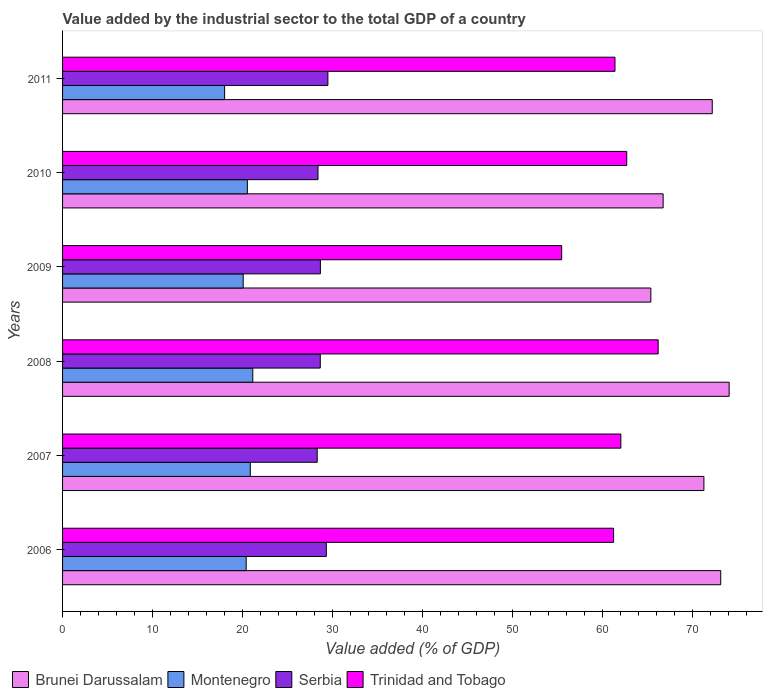How many different coloured bars are there?
Provide a succinct answer. 4. Are the number of bars per tick equal to the number of legend labels?
Your answer should be very brief. Yes. How many bars are there on the 4th tick from the top?
Ensure brevity in your answer.  4. What is the label of the 4th group of bars from the top?
Your answer should be very brief. 2008. In how many cases, is the number of bars for a given year not equal to the number of legend labels?
Offer a very short reply. 0. What is the value added by the industrial sector to the total GDP in Montenegro in 2006?
Make the answer very short. 20.41. Across all years, what is the maximum value added by the industrial sector to the total GDP in Serbia?
Provide a succinct answer. 29.5. Across all years, what is the minimum value added by the industrial sector to the total GDP in Serbia?
Your response must be concise. 28.31. In which year was the value added by the industrial sector to the total GDP in Brunei Darussalam minimum?
Offer a terse response. 2009. What is the total value added by the industrial sector to the total GDP in Brunei Darussalam in the graph?
Your answer should be very brief. 423.01. What is the difference between the value added by the industrial sector to the total GDP in Serbia in 2010 and that in 2011?
Your response must be concise. -1.1. What is the difference between the value added by the industrial sector to the total GDP in Brunei Darussalam in 2006 and the value added by the industrial sector to the total GDP in Montenegro in 2010?
Ensure brevity in your answer.  52.63. What is the average value added by the industrial sector to the total GDP in Brunei Darussalam per year?
Your answer should be compact. 70.5. In the year 2009, what is the difference between the value added by the industrial sector to the total GDP in Trinidad and Tobago and value added by the industrial sector to the total GDP in Brunei Darussalam?
Your answer should be compact. -9.91. What is the ratio of the value added by the industrial sector to the total GDP in Brunei Darussalam in 2006 to that in 2009?
Give a very brief answer. 1.12. Is the value added by the industrial sector to the total GDP in Brunei Darussalam in 2006 less than that in 2008?
Provide a succinct answer. Yes. What is the difference between the highest and the second highest value added by the industrial sector to the total GDP in Montenegro?
Provide a succinct answer. 0.28. What is the difference between the highest and the lowest value added by the industrial sector to the total GDP in Brunei Darussalam?
Offer a terse response. 8.71. What does the 2nd bar from the top in 2007 represents?
Make the answer very short. Serbia. What does the 4th bar from the bottom in 2011 represents?
Your response must be concise. Trinidad and Tobago. Is it the case that in every year, the sum of the value added by the industrial sector to the total GDP in Trinidad and Tobago and value added by the industrial sector to the total GDP in Brunei Darussalam is greater than the value added by the industrial sector to the total GDP in Serbia?
Keep it short and to the point. Yes. How many bars are there?
Give a very brief answer. 24. Are all the bars in the graph horizontal?
Provide a succinct answer. Yes. Does the graph contain any zero values?
Your answer should be very brief. No. How many legend labels are there?
Give a very brief answer. 4. How are the legend labels stacked?
Your response must be concise. Horizontal. What is the title of the graph?
Ensure brevity in your answer.  Value added by the industrial sector to the total GDP of a country. Does "Antigua and Barbuda" appear as one of the legend labels in the graph?
Ensure brevity in your answer.  No. What is the label or title of the X-axis?
Your answer should be very brief. Value added (% of GDP). What is the label or title of the Y-axis?
Offer a very short reply. Years. What is the Value added (% of GDP) of Brunei Darussalam in 2006?
Give a very brief answer. 73.18. What is the Value added (% of GDP) in Montenegro in 2006?
Offer a terse response. 20.41. What is the Value added (% of GDP) of Serbia in 2006?
Offer a very short reply. 29.33. What is the Value added (% of GDP) of Trinidad and Tobago in 2006?
Provide a succinct answer. 61.26. What is the Value added (% of GDP) in Brunei Darussalam in 2007?
Keep it short and to the point. 71.3. What is the Value added (% of GDP) of Montenegro in 2007?
Offer a very short reply. 20.87. What is the Value added (% of GDP) of Serbia in 2007?
Give a very brief answer. 28.31. What is the Value added (% of GDP) of Trinidad and Tobago in 2007?
Your answer should be very brief. 62.07. What is the Value added (% of GDP) in Brunei Darussalam in 2008?
Your response must be concise. 74.11. What is the Value added (% of GDP) in Montenegro in 2008?
Offer a terse response. 21.15. What is the Value added (% of GDP) of Serbia in 2008?
Make the answer very short. 28.65. What is the Value added (% of GDP) of Trinidad and Tobago in 2008?
Offer a very short reply. 66.22. What is the Value added (% of GDP) of Brunei Darussalam in 2009?
Ensure brevity in your answer.  65.41. What is the Value added (% of GDP) in Montenegro in 2009?
Provide a succinct answer. 20.08. What is the Value added (% of GDP) in Serbia in 2009?
Your response must be concise. 28.67. What is the Value added (% of GDP) of Trinidad and Tobago in 2009?
Your answer should be very brief. 55.49. What is the Value added (% of GDP) in Brunei Darussalam in 2010?
Provide a succinct answer. 66.77. What is the Value added (% of GDP) in Montenegro in 2010?
Provide a succinct answer. 20.54. What is the Value added (% of GDP) of Serbia in 2010?
Make the answer very short. 28.4. What is the Value added (% of GDP) in Trinidad and Tobago in 2010?
Provide a short and direct response. 62.72. What is the Value added (% of GDP) in Brunei Darussalam in 2011?
Give a very brief answer. 72.23. What is the Value added (% of GDP) in Montenegro in 2011?
Ensure brevity in your answer.  18.02. What is the Value added (% of GDP) in Serbia in 2011?
Offer a terse response. 29.5. What is the Value added (% of GDP) in Trinidad and Tobago in 2011?
Provide a succinct answer. 61.42. Across all years, what is the maximum Value added (% of GDP) in Brunei Darussalam?
Provide a succinct answer. 74.11. Across all years, what is the maximum Value added (% of GDP) in Montenegro?
Give a very brief answer. 21.15. Across all years, what is the maximum Value added (% of GDP) of Serbia?
Ensure brevity in your answer.  29.5. Across all years, what is the maximum Value added (% of GDP) of Trinidad and Tobago?
Your answer should be very brief. 66.22. Across all years, what is the minimum Value added (% of GDP) of Brunei Darussalam?
Your answer should be very brief. 65.41. Across all years, what is the minimum Value added (% of GDP) of Montenegro?
Ensure brevity in your answer.  18.02. Across all years, what is the minimum Value added (% of GDP) in Serbia?
Offer a very short reply. 28.31. Across all years, what is the minimum Value added (% of GDP) of Trinidad and Tobago?
Make the answer very short. 55.49. What is the total Value added (% of GDP) in Brunei Darussalam in the graph?
Keep it short and to the point. 423.01. What is the total Value added (% of GDP) of Montenegro in the graph?
Provide a short and direct response. 121.08. What is the total Value added (% of GDP) of Serbia in the graph?
Ensure brevity in your answer.  172.85. What is the total Value added (% of GDP) of Trinidad and Tobago in the graph?
Your response must be concise. 369.19. What is the difference between the Value added (% of GDP) in Brunei Darussalam in 2006 and that in 2007?
Make the answer very short. 1.87. What is the difference between the Value added (% of GDP) in Montenegro in 2006 and that in 2007?
Your answer should be very brief. -0.46. What is the difference between the Value added (% of GDP) in Serbia in 2006 and that in 2007?
Your answer should be very brief. 1.02. What is the difference between the Value added (% of GDP) in Trinidad and Tobago in 2006 and that in 2007?
Keep it short and to the point. -0.81. What is the difference between the Value added (% of GDP) of Brunei Darussalam in 2006 and that in 2008?
Offer a very short reply. -0.94. What is the difference between the Value added (% of GDP) in Montenegro in 2006 and that in 2008?
Provide a short and direct response. -0.73. What is the difference between the Value added (% of GDP) in Serbia in 2006 and that in 2008?
Give a very brief answer. 0.67. What is the difference between the Value added (% of GDP) in Trinidad and Tobago in 2006 and that in 2008?
Provide a succinct answer. -4.96. What is the difference between the Value added (% of GDP) in Brunei Darussalam in 2006 and that in 2009?
Your answer should be very brief. 7.77. What is the difference between the Value added (% of GDP) in Montenegro in 2006 and that in 2009?
Offer a terse response. 0.33. What is the difference between the Value added (% of GDP) in Serbia in 2006 and that in 2009?
Make the answer very short. 0.66. What is the difference between the Value added (% of GDP) of Trinidad and Tobago in 2006 and that in 2009?
Provide a short and direct response. 5.77. What is the difference between the Value added (% of GDP) in Brunei Darussalam in 2006 and that in 2010?
Make the answer very short. 6.4. What is the difference between the Value added (% of GDP) of Montenegro in 2006 and that in 2010?
Offer a terse response. -0.13. What is the difference between the Value added (% of GDP) in Serbia in 2006 and that in 2010?
Provide a short and direct response. 0.93. What is the difference between the Value added (% of GDP) of Trinidad and Tobago in 2006 and that in 2010?
Ensure brevity in your answer.  -1.46. What is the difference between the Value added (% of GDP) of Brunei Darussalam in 2006 and that in 2011?
Provide a succinct answer. 0.94. What is the difference between the Value added (% of GDP) of Montenegro in 2006 and that in 2011?
Your answer should be very brief. 2.4. What is the difference between the Value added (% of GDP) in Serbia in 2006 and that in 2011?
Your answer should be compact. -0.17. What is the difference between the Value added (% of GDP) of Trinidad and Tobago in 2006 and that in 2011?
Provide a succinct answer. -0.15. What is the difference between the Value added (% of GDP) in Brunei Darussalam in 2007 and that in 2008?
Keep it short and to the point. -2.81. What is the difference between the Value added (% of GDP) in Montenegro in 2007 and that in 2008?
Give a very brief answer. -0.28. What is the difference between the Value added (% of GDP) in Serbia in 2007 and that in 2008?
Make the answer very short. -0.34. What is the difference between the Value added (% of GDP) of Trinidad and Tobago in 2007 and that in 2008?
Your response must be concise. -4.15. What is the difference between the Value added (% of GDP) in Brunei Darussalam in 2007 and that in 2009?
Offer a very short reply. 5.9. What is the difference between the Value added (% of GDP) of Montenegro in 2007 and that in 2009?
Your answer should be very brief. 0.79. What is the difference between the Value added (% of GDP) in Serbia in 2007 and that in 2009?
Keep it short and to the point. -0.36. What is the difference between the Value added (% of GDP) of Trinidad and Tobago in 2007 and that in 2009?
Ensure brevity in your answer.  6.58. What is the difference between the Value added (% of GDP) in Brunei Darussalam in 2007 and that in 2010?
Offer a very short reply. 4.53. What is the difference between the Value added (% of GDP) in Montenegro in 2007 and that in 2010?
Make the answer very short. 0.33. What is the difference between the Value added (% of GDP) of Serbia in 2007 and that in 2010?
Offer a very short reply. -0.09. What is the difference between the Value added (% of GDP) of Trinidad and Tobago in 2007 and that in 2010?
Your response must be concise. -0.65. What is the difference between the Value added (% of GDP) of Brunei Darussalam in 2007 and that in 2011?
Give a very brief answer. -0.93. What is the difference between the Value added (% of GDP) in Montenegro in 2007 and that in 2011?
Offer a terse response. 2.86. What is the difference between the Value added (% of GDP) in Serbia in 2007 and that in 2011?
Make the answer very short. -1.19. What is the difference between the Value added (% of GDP) in Trinidad and Tobago in 2007 and that in 2011?
Provide a succinct answer. 0.65. What is the difference between the Value added (% of GDP) in Brunei Darussalam in 2008 and that in 2009?
Provide a short and direct response. 8.71. What is the difference between the Value added (% of GDP) in Montenegro in 2008 and that in 2009?
Offer a very short reply. 1.07. What is the difference between the Value added (% of GDP) of Serbia in 2008 and that in 2009?
Offer a terse response. -0.01. What is the difference between the Value added (% of GDP) in Trinidad and Tobago in 2008 and that in 2009?
Provide a short and direct response. 10.73. What is the difference between the Value added (% of GDP) of Brunei Darussalam in 2008 and that in 2010?
Your response must be concise. 7.34. What is the difference between the Value added (% of GDP) in Montenegro in 2008 and that in 2010?
Ensure brevity in your answer.  0.6. What is the difference between the Value added (% of GDP) in Serbia in 2008 and that in 2010?
Provide a succinct answer. 0.25. What is the difference between the Value added (% of GDP) in Trinidad and Tobago in 2008 and that in 2010?
Your answer should be compact. 3.5. What is the difference between the Value added (% of GDP) in Brunei Darussalam in 2008 and that in 2011?
Your response must be concise. 1.88. What is the difference between the Value added (% of GDP) of Montenegro in 2008 and that in 2011?
Keep it short and to the point. 3.13. What is the difference between the Value added (% of GDP) of Serbia in 2008 and that in 2011?
Offer a terse response. -0.85. What is the difference between the Value added (% of GDP) of Trinidad and Tobago in 2008 and that in 2011?
Your response must be concise. 4.8. What is the difference between the Value added (% of GDP) in Brunei Darussalam in 2009 and that in 2010?
Give a very brief answer. -1.37. What is the difference between the Value added (% of GDP) of Montenegro in 2009 and that in 2010?
Offer a very short reply. -0.46. What is the difference between the Value added (% of GDP) in Serbia in 2009 and that in 2010?
Keep it short and to the point. 0.27. What is the difference between the Value added (% of GDP) of Trinidad and Tobago in 2009 and that in 2010?
Keep it short and to the point. -7.23. What is the difference between the Value added (% of GDP) in Brunei Darussalam in 2009 and that in 2011?
Your answer should be compact. -6.83. What is the difference between the Value added (% of GDP) of Montenegro in 2009 and that in 2011?
Give a very brief answer. 2.07. What is the difference between the Value added (% of GDP) of Serbia in 2009 and that in 2011?
Offer a terse response. -0.83. What is the difference between the Value added (% of GDP) in Trinidad and Tobago in 2009 and that in 2011?
Provide a succinct answer. -5.93. What is the difference between the Value added (% of GDP) in Brunei Darussalam in 2010 and that in 2011?
Your response must be concise. -5.46. What is the difference between the Value added (% of GDP) in Montenegro in 2010 and that in 2011?
Offer a very short reply. 2.53. What is the difference between the Value added (% of GDP) in Serbia in 2010 and that in 2011?
Make the answer very short. -1.1. What is the difference between the Value added (% of GDP) in Trinidad and Tobago in 2010 and that in 2011?
Provide a short and direct response. 1.31. What is the difference between the Value added (% of GDP) in Brunei Darussalam in 2006 and the Value added (% of GDP) in Montenegro in 2007?
Provide a short and direct response. 52.3. What is the difference between the Value added (% of GDP) in Brunei Darussalam in 2006 and the Value added (% of GDP) in Serbia in 2007?
Provide a succinct answer. 44.87. What is the difference between the Value added (% of GDP) of Brunei Darussalam in 2006 and the Value added (% of GDP) of Trinidad and Tobago in 2007?
Offer a very short reply. 11.11. What is the difference between the Value added (% of GDP) in Montenegro in 2006 and the Value added (% of GDP) in Serbia in 2007?
Your answer should be compact. -7.9. What is the difference between the Value added (% of GDP) of Montenegro in 2006 and the Value added (% of GDP) of Trinidad and Tobago in 2007?
Offer a terse response. -41.66. What is the difference between the Value added (% of GDP) of Serbia in 2006 and the Value added (% of GDP) of Trinidad and Tobago in 2007?
Provide a short and direct response. -32.74. What is the difference between the Value added (% of GDP) in Brunei Darussalam in 2006 and the Value added (% of GDP) in Montenegro in 2008?
Give a very brief answer. 52.03. What is the difference between the Value added (% of GDP) in Brunei Darussalam in 2006 and the Value added (% of GDP) in Serbia in 2008?
Your answer should be compact. 44.52. What is the difference between the Value added (% of GDP) in Brunei Darussalam in 2006 and the Value added (% of GDP) in Trinidad and Tobago in 2008?
Give a very brief answer. 6.96. What is the difference between the Value added (% of GDP) of Montenegro in 2006 and the Value added (% of GDP) of Serbia in 2008?
Provide a succinct answer. -8.24. What is the difference between the Value added (% of GDP) in Montenegro in 2006 and the Value added (% of GDP) in Trinidad and Tobago in 2008?
Your answer should be very brief. -45.81. What is the difference between the Value added (% of GDP) in Serbia in 2006 and the Value added (% of GDP) in Trinidad and Tobago in 2008?
Make the answer very short. -36.89. What is the difference between the Value added (% of GDP) in Brunei Darussalam in 2006 and the Value added (% of GDP) in Montenegro in 2009?
Provide a short and direct response. 53.1. What is the difference between the Value added (% of GDP) in Brunei Darussalam in 2006 and the Value added (% of GDP) in Serbia in 2009?
Your answer should be compact. 44.51. What is the difference between the Value added (% of GDP) of Brunei Darussalam in 2006 and the Value added (% of GDP) of Trinidad and Tobago in 2009?
Offer a very short reply. 17.69. What is the difference between the Value added (% of GDP) of Montenegro in 2006 and the Value added (% of GDP) of Serbia in 2009?
Your answer should be very brief. -8.25. What is the difference between the Value added (% of GDP) in Montenegro in 2006 and the Value added (% of GDP) in Trinidad and Tobago in 2009?
Provide a short and direct response. -35.08. What is the difference between the Value added (% of GDP) of Serbia in 2006 and the Value added (% of GDP) of Trinidad and Tobago in 2009?
Your answer should be very brief. -26.17. What is the difference between the Value added (% of GDP) of Brunei Darussalam in 2006 and the Value added (% of GDP) of Montenegro in 2010?
Your answer should be compact. 52.63. What is the difference between the Value added (% of GDP) in Brunei Darussalam in 2006 and the Value added (% of GDP) in Serbia in 2010?
Keep it short and to the point. 44.78. What is the difference between the Value added (% of GDP) of Brunei Darussalam in 2006 and the Value added (% of GDP) of Trinidad and Tobago in 2010?
Ensure brevity in your answer.  10.45. What is the difference between the Value added (% of GDP) of Montenegro in 2006 and the Value added (% of GDP) of Serbia in 2010?
Give a very brief answer. -7.99. What is the difference between the Value added (% of GDP) in Montenegro in 2006 and the Value added (% of GDP) in Trinidad and Tobago in 2010?
Provide a short and direct response. -42.31. What is the difference between the Value added (% of GDP) in Serbia in 2006 and the Value added (% of GDP) in Trinidad and Tobago in 2010?
Offer a terse response. -33.4. What is the difference between the Value added (% of GDP) of Brunei Darussalam in 2006 and the Value added (% of GDP) of Montenegro in 2011?
Your answer should be compact. 55.16. What is the difference between the Value added (% of GDP) in Brunei Darussalam in 2006 and the Value added (% of GDP) in Serbia in 2011?
Your answer should be very brief. 43.68. What is the difference between the Value added (% of GDP) of Brunei Darussalam in 2006 and the Value added (% of GDP) of Trinidad and Tobago in 2011?
Your response must be concise. 11.76. What is the difference between the Value added (% of GDP) in Montenegro in 2006 and the Value added (% of GDP) in Serbia in 2011?
Offer a very short reply. -9.08. What is the difference between the Value added (% of GDP) in Montenegro in 2006 and the Value added (% of GDP) in Trinidad and Tobago in 2011?
Your answer should be compact. -41. What is the difference between the Value added (% of GDP) in Serbia in 2006 and the Value added (% of GDP) in Trinidad and Tobago in 2011?
Provide a succinct answer. -32.09. What is the difference between the Value added (% of GDP) of Brunei Darussalam in 2007 and the Value added (% of GDP) of Montenegro in 2008?
Provide a short and direct response. 50.16. What is the difference between the Value added (% of GDP) of Brunei Darussalam in 2007 and the Value added (% of GDP) of Serbia in 2008?
Give a very brief answer. 42.65. What is the difference between the Value added (% of GDP) in Brunei Darussalam in 2007 and the Value added (% of GDP) in Trinidad and Tobago in 2008?
Keep it short and to the point. 5.08. What is the difference between the Value added (% of GDP) of Montenegro in 2007 and the Value added (% of GDP) of Serbia in 2008?
Your answer should be compact. -7.78. What is the difference between the Value added (% of GDP) in Montenegro in 2007 and the Value added (% of GDP) in Trinidad and Tobago in 2008?
Offer a terse response. -45.35. What is the difference between the Value added (% of GDP) of Serbia in 2007 and the Value added (% of GDP) of Trinidad and Tobago in 2008?
Offer a very short reply. -37.91. What is the difference between the Value added (% of GDP) in Brunei Darussalam in 2007 and the Value added (% of GDP) in Montenegro in 2009?
Give a very brief answer. 51.22. What is the difference between the Value added (% of GDP) in Brunei Darussalam in 2007 and the Value added (% of GDP) in Serbia in 2009?
Your answer should be very brief. 42.64. What is the difference between the Value added (% of GDP) in Brunei Darussalam in 2007 and the Value added (% of GDP) in Trinidad and Tobago in 2009?
Your answer should be very brief. 15.81. What is the difference between the Value added (% of GDP) in Montenegro in 2007 and the Value added (% of GDP) in Serbia in 2009?
Make the answer very short. -7.79. What is the difference between the Value added (% of GDP) in Montenegro in 2007 and the Value added (% of GDP) in Trinidad and Tobago in 2009?
Make the answer very short. -34.62. What is the difference between the Value added (% of GDP) of Serbia in 2007 and the Value added (% of GDP) of Trinidad and Tobago in 2009?
Provide a succinct answer. -27.18. What is the difference between the Value added (% of GDP) in Brunei Darussalam in 2007 and the Value added (% of GDP) in Montenegro in 2010?
Provide a short and direct response. 50.76. What is the difference between the Value added (% of GDP) of Brunei Darussalam in 2007 and the Value added (% of GDP) of Serbia in 2010?
Keep it short and to the point. 42.9. What is the difference between the Value added (% of GDP) of Brunei Darussalam in 2007 and the Value added (% of GDP) of Trinidad and Tobago in 2010?
Ensure brevity in your answer.  8.58. What is the difference between the Value added (% of GDP) of Montenegro in 2007 and the Value added (% of GDP) of Serbia in 2010?
Offer a terse response. -7.53. What is the difference between the Value added (% of GDP) in Montenegro in 2007 and the Value added (% of GDP) in Trinidad and Tobago in 2010?
Give a very brief answer. -41.85. What is the difference between the Value added (% of GDP) in Serbia in 2007 and the Value added (% of GDP) in Trinidad and Tobago in 2010?
Provide a succinct answer. -34.41. What is the difference between the Value added (% of GDP) in Brunei Darussalam in 2007 and the Value added (% of GDP) in Montenegro in 2011?
Your answer should be very brief. 53.29. What is the difference between the Value added (% of GDP) of Brunei Darussalam in 2007 and the Value added (% of GDP) of Serbia in 2011?
Make the answer very short. 41.81. What is the difference between the Value added (% of GDP) of Brunei Darussalam in 2007 and the Value added (% of GDP) of Trinidad and Tobago in 2011?
Offer a very short reply. 9.89. What is the difference between the Value added (% of GDP) in Montenegro in 2007 and the Value added (% of GDP) in Serbia in 2011?
Give a very brief answer. -8.63. What is the difference between the Value added (% of GDP) of Montenegro in 2007 and the Value added (% of GDP) of Trinidad and Tobago in 2011?
Give a very brief answer. -40.55. What is the difference between the Value added (% of GDP) of Serbia in 2007 and the Value added (% of GDP) of Trinidad and Tobago in 2011?
Keep it short and to the point. -33.11. What is the difference between the Value added (% of GDP) of Brunei Darussalam in 2008 and the Value added (% of GDP) of Montenegro in 2009?
Your answer should be very brief. 54.03. What is the difference between the Value added (% of GDP) in Brunei Darussalam in 2008 and the Value added (% of GDP) in Serbia in 2009?
Offer a terse response. 45.45. What is the difference between the Value added (% of GDP) of Brunei Darussalam in 2008 and the Value added (% of GDP) of Trinidad and Tobago in 2009?
Provide a succinct answer. 18.62. What is the difference between the Value added (% of GDP) of Montenegro in 2008 and the Value added (% of GDP) of Serbia in 2009?
Make the answer very short. -7.52. What is the difference between the Value added (% of GDP) of Montenegro in 2008 and the Value added (% of GDP) of Trinidad and Tobago in 2009?
Make the answer very short. -34.34. What is the difference between the Value added (% of GDP) of Serbia in 2008 and the Value added (% of GDP) of Trinidad and Tobago in 2009?
Give a very brief answer. -26.84. What is the difference between the Value added (% of GDP) of Brunei Darussalam in 2008 and the Value added (% of GDP) of Montenegro in 2010?
Make the answer very short. 53.57. What is the difference between the Value added (% of GDP) in Brunei Darussalam in 2008 and the Value added (% of GDP) in Serbia in 2010?
Ensure brevity in your answer.  45.71. What is the difference between the Value added (% of GDP) in Brunei Darussalam in 2008 and the Value added (% of GDP) in Trinidad and Tobago in 2010?
Make the answer very short. 11.39. What is the difference between the Value added (% of GDP) of Montenegro in 2008 and the Value added (% of GDP) of Serbia in 2010?
Your answer should be very brief. -7.25. What is the difference between the Value added (% of GDP) in Montenegro in 2008 and the Value added (% of GDP) in Trinidad and Tobago in 2010?
Your answer should be very brief. -41.58. What is the difference between the Value added (% of GDP) of Serbia in 2008 and the Value added (% of GDP) of Trinidad and Tobago in 2010?
Offer a terse response. -34.07. What is the difference between the Value added (% of GDP) in Brunei Darussalam in 2008 and the Value added (% of GDP) in Montenegro in 2011?
Your response must be concise. 56.1. What is the difference between the Value added (% of GDP) of Brunei Darussalam in 2008 and the Value added (% of GDP) of Serbia in 2011?
Provide a succinct answer. 44.61. What is the difference between the Value added (% of GDP) of Brunei Darussalam in 2008 and the Value added (% of GDP) of Trinidad and Tobago in 2011?
Ensure brevity in your answer.  12.69. What is the difference between the Value added (% of GDP) in Montenegro in 2008 and the Value added (% of GDP) in Serbia in 2011?
Give a very brief answer. -8.35. What is the difference between the Value added (% of GDP) in Montenegro in 2008 and the Value added (% of GDP) in Trinidad and Tobago in 2011?
Provide a succinct answer. -40.27. What is the difference between the Value added (% of GDP) of Serbia in 2008 and the Value added (% of GDP) of Trinidad and Tobago in 2011?
Offer a terse response. -32.77. What is the difference between the Value added (% of GDP) of Brunei Darussalam in 2009 and the Value added (% of GDP) of Montenegro in 2010?
Your answer should be very brief. 44.86. What is the difference between the Value added (% of GDP) in Brunei Darussalam in 2009 and the Value added (% of GDP) in Serbia in 2010?
Ensure brevity in your answer.  37.01. What is the difference between the Value added (% of GDP) in Brunei Darussalam in 2009 and the Value added (% of GDP) in Trinidad and Tobago in 2010?
Your answer should be compact. 2.68. What is the difference between the Value added (% of GDP) of Montenegro in 2009 and the Value added (% of GDP) of Serbia in 2010?
Provide a short and direct response. -8.32. What is the difference between the Value added (% of GDP) of Montenegro in 2009 and the Value added (% of GDP) of Trinidad and Tobago in 2010?
Your response must be concise. -42.64. What is the difference between the Value added (% of GDP) in Serbia in 2009 and the Value added (% of GDP) in Trinidad and Tobago in 2010?
Offer a terse response. -34.06. What is the difference between the Value added (% of GDP) in Brunei Darussalam in 2009 and the Value added (% of GDP) in Montenegro in 2011?
Your response must be concise. 47.39. What is the difference between the Value added (% of GDP) of Brunei Darussalam in 2009 and the Value added (% of GDP) of Serbia in 2011?
Provide a short and direct response. 35.91. What is the difference between the Value added (% of GDP) of Brunei Darussalam in 2009 and the Value added (% of GDP) of Trinidad and Tobago in 2011?
Your answer should be very brief. 3.99. What is the difference between the Value added (% of GDP) of Montenegro in 2009 and the Value added (% of GDP) of Serbia in 2011?
Your answer should be very brief. -9.42. What is the difference between the Value added (% of GDP) in Montenegro in 2009 and the Value added (% of GDP) in Trinidad and Tobago in 2011?
Offer a terse response. -41.34. What is the difference between the Value added (% of GDP) of Serbia in 2009 and the Value added (% of GDP) of Trinidad and Tobago in 2011?
Make the answer very short. -32.75. What is the difference between the Value added (% of GDP) in Brunei Darussalam in 2010 and the Value added (% of GDP) in Montenegro in 2011?
Make the answer very short. 48.76. What is the difference between the Value added (% of GDP) in Brunei Darussalam in 2010 and the Value added (% of GDP) in Serbia in 2011?
Ensure brevity in your answer.  37.27. What is the difference between the Value added (% of GDP) in Brunei Darussalam in 2010 and the Value added (% of GDP) in Trinidad and Tobago in 2011?
Offer a very short reply. 5.36. What is the difference between the Value added (% of GDP) of Montenegro in 2010 and the Value added (% of GDP) of Serbia in 2011?
Offer a very short reply. -8.95. What is the difference between the Value added (% of GDP) in Montenegro in 2010 and the Value added (% of GDP) in Trinidad and Tobago in 2011?
Make the answer very short. -40.87. What is the difference between the Value added (% of GDP) of Serbia in 2010 and the Value added (% of GDP) of Trinidad and Tobago in 2011?
Provide a succinct answer. -33.02. What is the average Value added (% of GDP) of Brunei Darussalam per year?
Your answer should be very brief. 70.5. What is the average Value added (% of GDP) of Montenegro per year?
Give a very brief answer. 20.18. What is the average Value added (% of GDP) of Serbia per year?
Offer a terse response. 28.81. What is the average Value added (% of GDP) of Trinidad and Tobago per year?
Offer a terse response. 61.53. In the year 2006, what is the difference between the Value added (% of GDP) in Brunei Darussalam and Value added (% of GDP) in Montenegro?
Give a very brief answer. 52.76. In the year 2006, what is the difference between the Value added (% of GDP) of Brunei Darussalam and Value added (% of GDP) of Serbia?
Your response must be concise. 43.85. In the year 2006, what is the difference between the Value added (% of GDP) of Brunei Darussalam and Value added (% of GDP) of Trinidad and Tobago?
Your response must be concise. 11.91. In the year 2006, what is the difference between the Value added (% of GDP) in Montenegro and Value added (% of GDP) in Serbia?
Keep it short and to the point. -8.91. In the year 2006, what is the difference between the Value added (% of GDP) in Montenegro and Value added (% of GDP) in Trinidad and Tobago?
Your answer should be compact. -40.85. In the year 2006, what is the difference between the Value added (% of GDP) of Serbia and Value added (% of GDP) of Trinidad and Tobago?
Provide a short and direct response. -31.94. In the year 2007, what is the difference between the Value added (% of GDP) of Brunei Darussalam and Value added (% of GDP) of Montenegro?
Give a very brief answer. 50.43. In the year 2007, what is the difference between the Value added (% of GDP) of Brunei Darussalam and Value added (% of GDP) of Serbia?
Your response must be concise. 42.99. In the year 2007, what is the difference between the Value added (% of GDP) in Brunei Darussalam and Value added (% of GDP) in Trinidad and Tobago?
Your answer should be very brief. 9.23. In the year 2007, what is the difference between the Value added (% of GDP) of Montenegro and Value added (% of GDP) of Serbia?
Offer a very short reply. -7.44. In the year 2007, what is the difference between the Value added (% of GDP) in Montenegro and Value added (% of GDP) in Trinidad and Tobago?
Provide a short and direct response. -41.2. In the year 2007, what is the difference between the Value added (% of GDP) in Serbia and Value added (% of GDP) in Trinidad and Tobago?
Offer a terse response. -33.76. In the year 2008, what is the difference between the Value added (% of GDP) in Brunei Darussalam and Value added (% of GDP) in Montenegro?
Provide a short and direct response. 52.96. In the year 2008, what is the difference between the Value added (% of GDP) of Brunei Darussalam and Value added (% of GDP) of Serbia?
Ensure brevity in your answer.  45.46. In the year 2008, what is the difference between the Value added (% of GDP) of Brunei Darussalam and Value added (% of GDP) of Trinidad and Tobago?
Offer a very short reply. 7.89. In the year 2008, what is the difference between the Value added (% of GDP) in Montenegro and Value added (% of GDP) in Serbia?
Provide a succinct answer. -7.5. In the year 2008, what is the difference between the Value added (% of GDP) in Montenegro and Value added (% of GDP) in Trinidad and Tobago?
Make the answer very short. -45.07. In the year 2008, what is the difference between the Value added (% of GDP) in Serbia and Value added (% of GDP) in Trinidad and Tobago?
Give a very brief answer. -37.57. In the year 2009, what is the difference between the Value added (% of GDP) in Brunei Darussalam and Value added (% of GDP) in Montenegro?
Ensure brevity in your answer.  45.32. In the year 2009, what is the difference between the Value added (% of GDP) in Brunei Darussalam and Value added (% of GDP) in Serbia?
Keep it short and to the point. 36.74. In the year 2009, what is the difference between the Value added (% of GDP) of Brunei Darussalam and Value added (% of GDP) of Trinidad and Tobago?
Offer a terse response. 9.91. In the year 2009, what is the difference between the Value added (% of GDP) in Montenegro and Value added (% of GDP) in Serbia?
Offer a very short reply. -8.58. In the year 2009, what is the difference between the Value added (% of GDP) of Montenegro and Value added (% of GDP) of Trinidad and Tobago?
Provide a short and direct response. -35.41. In the year 2009, what is the difference between the Value added (% of GDP) of Serbia and Value added (% of GDP) of Trinidad and Tobago?
Offer a terse response. -26.83. In the year 2010, what is the difference between the Value added (% of GDP) in Brunei Darussalam and Value added (% of GDP) in Montenegro?
Your answer should be compact. 46.23. In the year 2010, what is the difference between the Value added (% of GDP) of Brunei Darussalam and Value added (% of GDP) of Serbia?
Keep it short and to the point. 38.37. In the year 2010, what is the difference between the Value added (% of GDP) of Brunei Darussalam and Value added (% of GDP) of Trinidad and Tobago?
Make the answer very short. 4.05. In the year 2010, what is the difference between the Value added (% of GDP) of Montenegro and Value added (% of GDP) of Serbia?
Keep it short and to the point. -7.86. In the year 2010, what is the difference between the Value added (% of GDP) of Montenegro and Value added (% of GDP) of Trinidad and Tobago?
Your response must be concise. -42.18. In the year 2010, what is the difference between the Value added (% of GDP) in Serbia and Value added (% of GDP) in Trinidad and Tobago?
Keep it short and to the point. -34.32. In the year 2011, what is the difference between the Value added (% of GDP) of Brunei Darussalam and Value added (% of GDP) of Montenegro?
Provide a succinct answer. 54.22. In the year 2011, what is the difference between the Value added (% of GDP) of Brunei Darussalam and Value added (% of GDP) of Serbia?
Keep it short and to the point. 42.73. In the year 2011, what is the difference between the Value added (% of GDP) of Brunei Darussalam and Value added (% of GDP) of Trinidad and Tobago?
Ensure brevity in your answer.  10.82. In the year 2011, what is the difference between the Value added (% of GDP) of Montenegro and Value added (% of GDP) of Serbia?
Offer a very short reply. -11.48. In the year 2011, what is the difference between the Value added (% of GDP) of Montenegro and Value added (% of GDP) of Trinidad and Tobago?
Your answer should be compact. -43.4. In the year 2011, what is the difference between the Value added (% of GDP) of Serbia and Value added (% of GDP) of Trinidad and Tobago?
Your answer should be compact. -31.92. What is the ratio of the Value added (% of GDP) in Brunei Darussalam in 2006 to that in 2007?
Offer a very short reply. 1.03. What is the ratio of the Value added (% of GDP) in Montenegro in 2006 to that in 2007?
Your response must be concise. 0.98. What is the ratio of the Value added (% of GDP) in Serbia in 2006 to that in 2007?
Your answer should be compact. 1.04. What is the ratio of the Value added (% of GDP) of Trinidad and Tobago in 2006 to that in 2007?
Your response must be concise. 0.99. What is the ratio of the Value added (% of GDP) in Brunei Darussalam in 2006 to that in 2008?
Provide a succinct answer. 0.99. What is the ratio of the Value added (% of GDP) of Montenegro in 2006 to that in 2008?
Provide a succinct answer. 0.97. What is the ratio of the Value added (% of GDP) of Serbia in 2006 to that in 2008?
Give a very brief answer. 1.02. What is the ratio of the Value added (% of GDP) of Trinidad and Tobago in 2006 to that in 2008?
Make the answer very short. 0.93. What is the ratio of the Value added (% of GDP) of Brunei Darussalam in 2006 to that in 2009?
Provide a succinct answer. 1.12. What is the ratio of the Value added (% of GDP) of Montenegro in 2006 to that in 2009?
Your answer should be very brief. 1.02. What is the ratio of the Value added (% of GDP) of Trinidad and Tobago in 2006 to that in 2009?
Give a very brief answer. 1.1. What is the ratio of the Value added (% of GDP) in Brunei Darussalam in 2006 to that in 2010?
Offer a terse response. 1.1. What is the ratio of the Value added (% of GDP) in Montenegro in 2006 to that in 2010?
Keep it short and to the point. 0.99. What is the ratio of the Value added (% of GDP) of Serbia in 2006 to that in 2010?
Provide a succinct answer. 1.03. What is the ratio of the Value added (% of GDP) in Trinidad and Tobago in 2006 to that in 2010?
Keep it short and to the point. 0.98. What is the ratio of the Value added (% of GDP) of Brunei Darussalam in 2006 to that in 2011?
Your answer should be compact. 1.01. What is the ratio of the Value added (% of GDP) of Montenegro in 2006 to that in 2011?
Ensure brevity in your answer.  1.13. What is the ratio of the Value added (% of GDP) in Brunei Darussalam in 2007 to that in 2008?
Give a very brief answer. 0.96. What is the ratio of the Value added (% of GDP) of Montenegro in 2007 to that in 2008?
Offer a very short reply. 0.99. What is the ratio of the Value added (% of GDP) of Trinidad and Tobago in 2007 to that in 2008?
Ensure brevity in your answer.  0.94. What is the ratio of the Value added (% of GDP) in Brunei Darussalam in 2007 to that in 2009?
Ensure brevity in your answer.  1.09. What is the ratio of the Value added (% of GDP) of Montenegro in 2007 to that in 2009?
Keep it short and to the point. 1.04. What is the ratio of the Value added (% of GDP) in Serbia in 2007 to that in 2009?
Give a very brief answer. 0.99. What is the ratio of the Value added (% of GDP) of Trinidad and Tobago in 2007 to that in 2009?
Your answer should be compact. 1.12. What is the ratio of the Value added (% of GDP) in Brunei Darussalam in 2007 to that in 2010?
Provide a short and direct response. 1.07. What is the ratio of the Value added (% of GDP) of Montenegro in 2007 to that in 2010?
Your answer should be very brief. 1.02. What is the ratio of the Value added (% of GDP) of Brunei Darussalam in 2007 to that in 2011?
Offer a terse response. 0.99. What is the ratio of the Value added (% of GDP) of Montenegro in 2007 to that in 2011?
Ensure brevity in your answer.  1.16. What is the ratio of the Value added (% of GDP) in Serbia in 2007 to that in 2011?
Your response must be concise. 0.96. What is the ratio of the Value added (% of GDP) in Trinidad and Tobago in 2007 to that in 2011?
Your response must be concise. 1.01. What is the ratio of the Value added (% of GDP) in Brunei Darussalam in 2008 to that in 2009?
Give a very brief answer. 1.13. What is the ratio of the Value added (% of GDP) in Montenegro in 2008 to that in 2009?
Give a very brief answer. 1.05. What is the ratio of the Value added (% of GDP) in Trinidad and Tobago in 2008 to that in 2009?
Ensure brevity in your answer.  1.19. What is the ratio of the Value added (% of GDP) of Brunei Darussalam in 2008 to that in 2010?
Make the answer very short. 1.11. What is the ratio of the Value added (% of GDP) in Montenegro in 2008 to that in 2010?
Offer a terse response. 1.03. What is the ratio of the Value added (% of GDP) of Serbia in 2008 to that in 2010?
Provide a short and direct response. 1.01. What is the ratio of the Value added (% of GDP) of Trinidad and Tobago in 2008 to that in 2010?
Offer a terse response. 1.06. What is the ratio of the Value added (% of GDP) in Montenegro in 2008 to that in 2011?
Your answer should be very brief. 1.17. What is the ratio of the Value added (% of GDP) of Serbia in 2008 to that in 2011?
Make the answer very short. 0.97. What is the ratio of the Value added (% of GDP) in Trinidad and Tobago in 2008 to that in 2011?
Your answer should be compact. 1.08. What is the ratio of the Value added (% of GDP) in Brunei Darussalam in 2009 to that in 2010?
Provide a short and direct response. 0.98. What is the ratio of the Value added (% of GDP) in Montenegro in 2009 to that in 2010?
Provide a succinct answer. 0.98. What is the ratio of the Value added (% of GDP) in Serbia in 2009 to that in 2010?
Offer a terse response. 1.01. What is the ratio of the Value added (% of GDP) in Trinidad and Tobago in 2009 to that in 2010?
Make the answer very short. 0.88. What is the ratio of the Value added (% of GDP) of Brunei Darussalam in 2009 to that in 2011?
Your answer should be very brief. 0.91. What is the ratio of the Value added (% of GDP) in Montenegro in 2009 to that in 2011?
Make the answer very short. 1.11. What is the ratio of the Value added (% of GDP) of Serbia in 2009 to that in 2011?
Give a very brief answer. 0.97. What is the ratio of the Value added (% of GDP) of Trinidad and Tobago in 2009 to that in 2011?
Your answer should be very brief. 0.9. What is the ratio of the Value added (% of GDP) in Brunei Darussalam in 2010 to that in 2011?
Keep it short and to the point. 0.92. What is the ratio of the Value added (% of GDP) in Montenegro in 2010 to that in 2011?
Offer a terse response. 1.14. What is the ratio of the Value added (% of GDP) in Serbia in 2010 to that in 2011?
Keep it short and to the point. 0.96. What is the ratio of the Value added (% of GDP) of Trinidad and Tobago in 2010 to that in 2011?
Provide a succinct answer. 1.02. What is the difference between the highest and the second highest Value added (% of GDP) in Brunei Darussalam?
Give a very brief answer. 0.94. What is the difference between the highest and the second highest Value added (% of GDP) in Montenegro?
Offer a terse response. 0.28. What is the difference between the highest and the second highest Value added (% of GDP) of Serbia?
Provide a succinct answer. 0.17. What is the difference between the highest and the second highest Value added (% of GDP) of Trinidad and Tobago?
Give a very brief answer. 3.5. What is the difference between the highest and the lowest Value added (% of GDP) in Brunei Darussalam?
Provide a succinct answer. 8.71. What is the difference between the highest and the lowest Value added (% of GDP) in Montenegro?
Offer a terse response. 3.13. What is the difference between the highest and the lowest Value added (% of GDP) of Serbia?
Provide a short and direct response. 1.19. What is the difference between the highest and the lowest Value added (% of GDP) in Trinidad and Tobago?
Offer a very short reply. 10.73. 